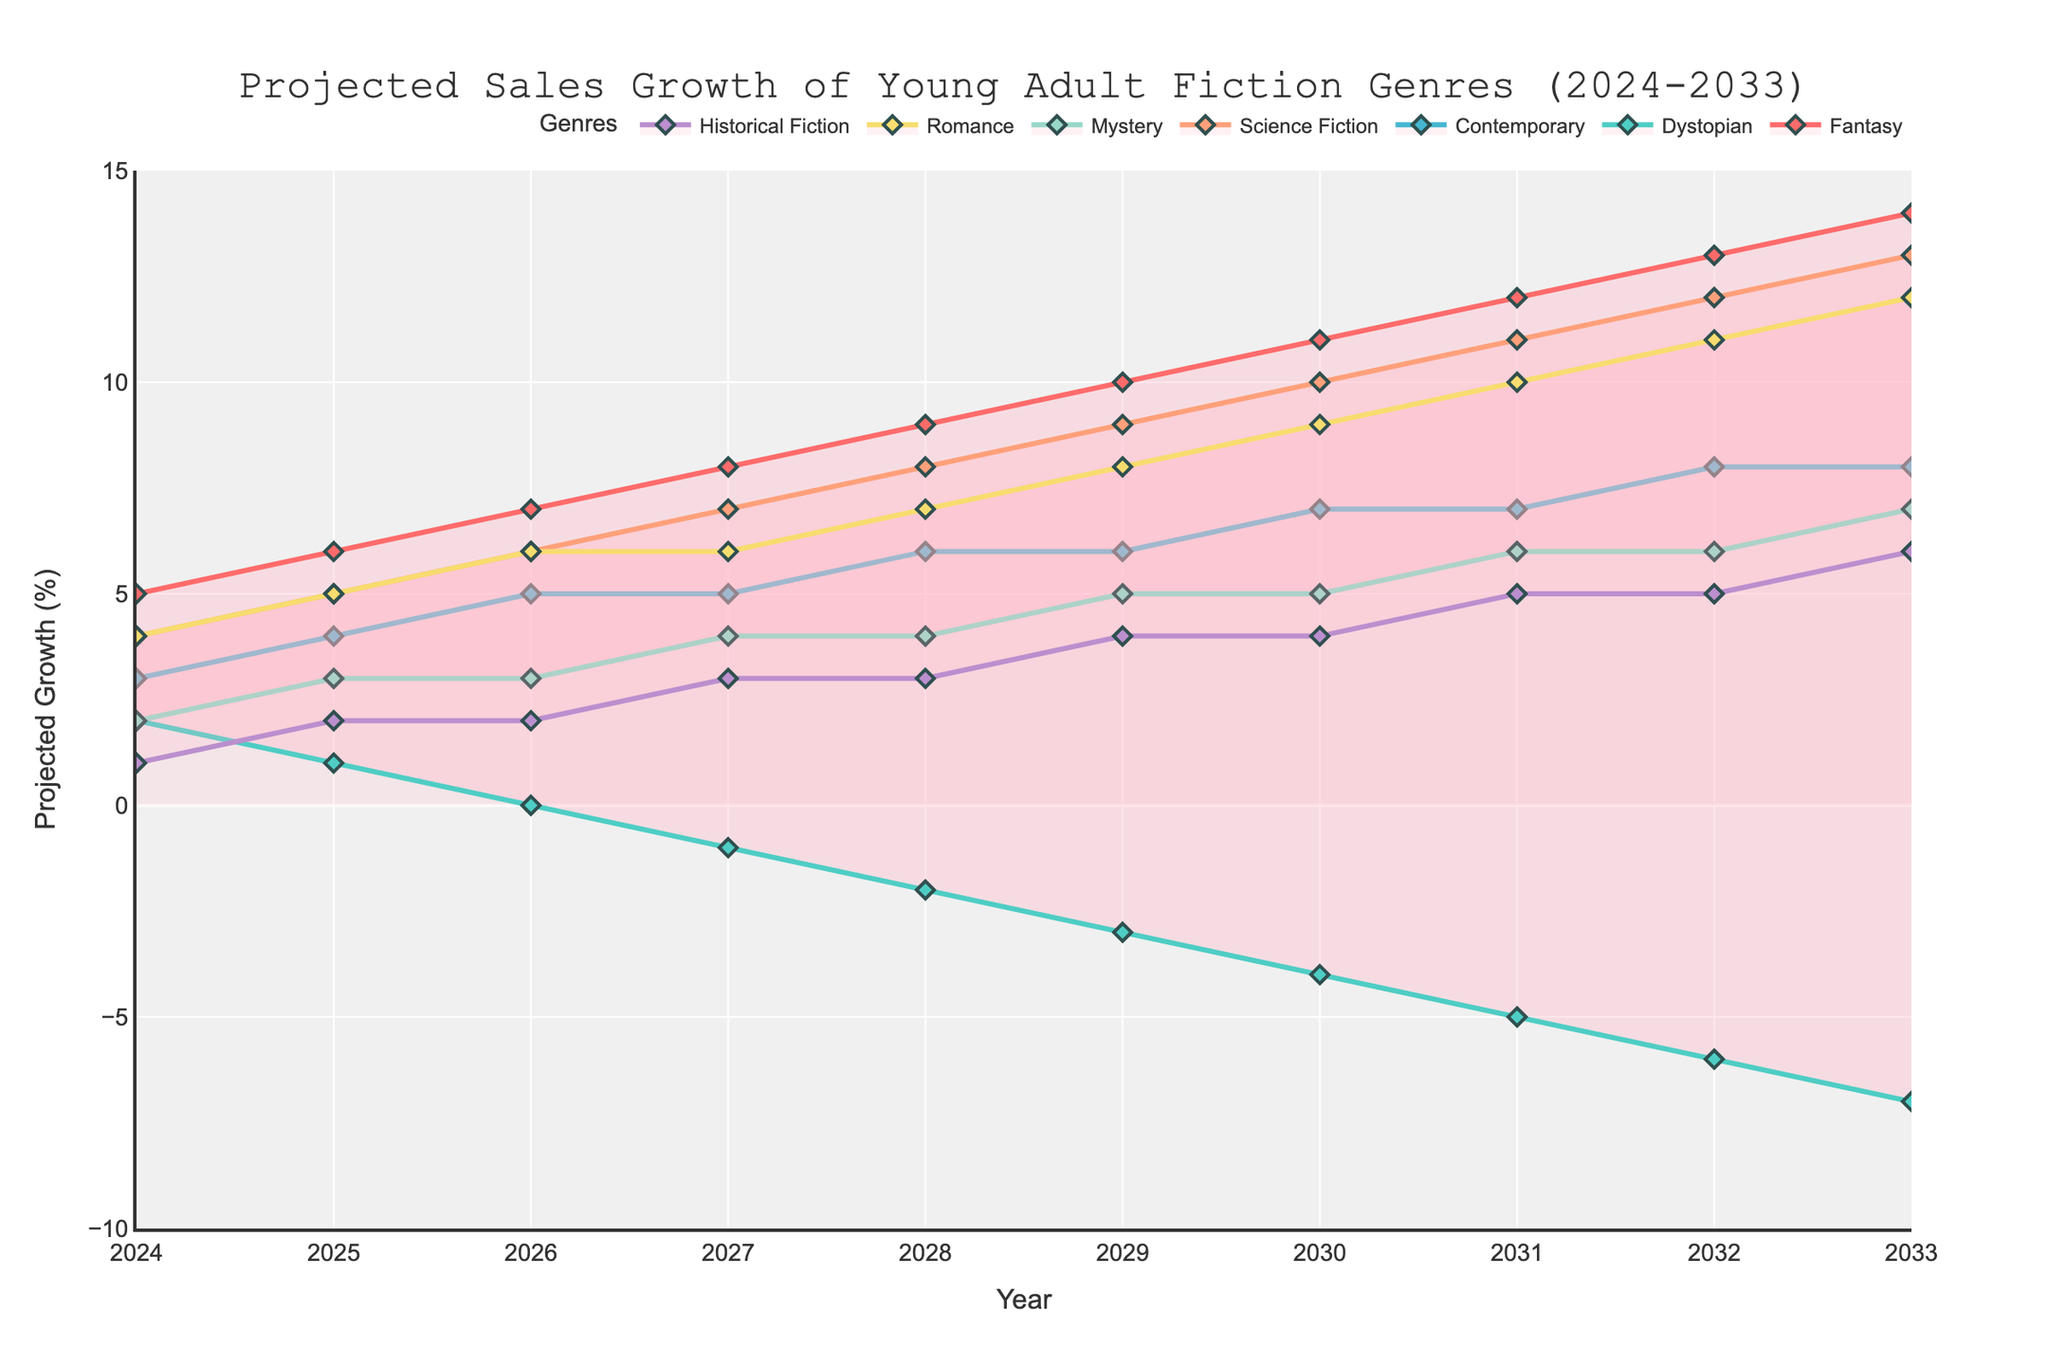what is the title of the figure? The title of the figure is located at the top center of the plot. It is clearly identified as the overall description of what the figure represents.
Answer: Projected Sales Growth of Young Adult Fiction Genres (2024-2033) What years are included in this projection? The years are shown on the x-axis of the plot. They range from the starting year to the ending year.
Answer: 2024 to 2033 Which genre is projected to have negative growth by 2033? By looking at the trend lines, you can see which line dips into negative values on the y-axis by the year 2033.
Answer: Dystopian What genre is expected to have the highest growth in 2028? Look at the y-values for the year 2028 and determine which genre has the highest point.
Answer: Fantasy Between which years does Mystery genre remain constant? Check the y-values for the Mystery genre line and find the years between which the value does not change.
Answer: 2026 and 2028 What is the difference in projected growth between Romance and Historical Fiction in 2030? Read the y-values for Romance and Historical Fiction in the year 2030 and subtract the Historical Fiction value from the Romance value.
Answer: 5 Which genre has the least projected growth in 2024? Find the lowest y-value among all genres in the year 2024 and determine which genre it belongs to.
Answer: Historical Fiction How many genres are projected to have positive growth in 2033? Count the number of lines that have a positive y-value in the year 2033.
Answer: 6 Compare the growth trends of Fantasy and Science Fiction genres. What can be inferred? Analyze the patterns of the lines representing Fantasy and Science Fiction: consider direction, slope, and intersection points.
Answer: Both trends are increasing, but Fantasy grows faster What is the overall trend for Contemporary genre over the decade? Observe the overall direction of the Contemporary genre line from 2024 to 2033.
Answer: Increasing steadily 